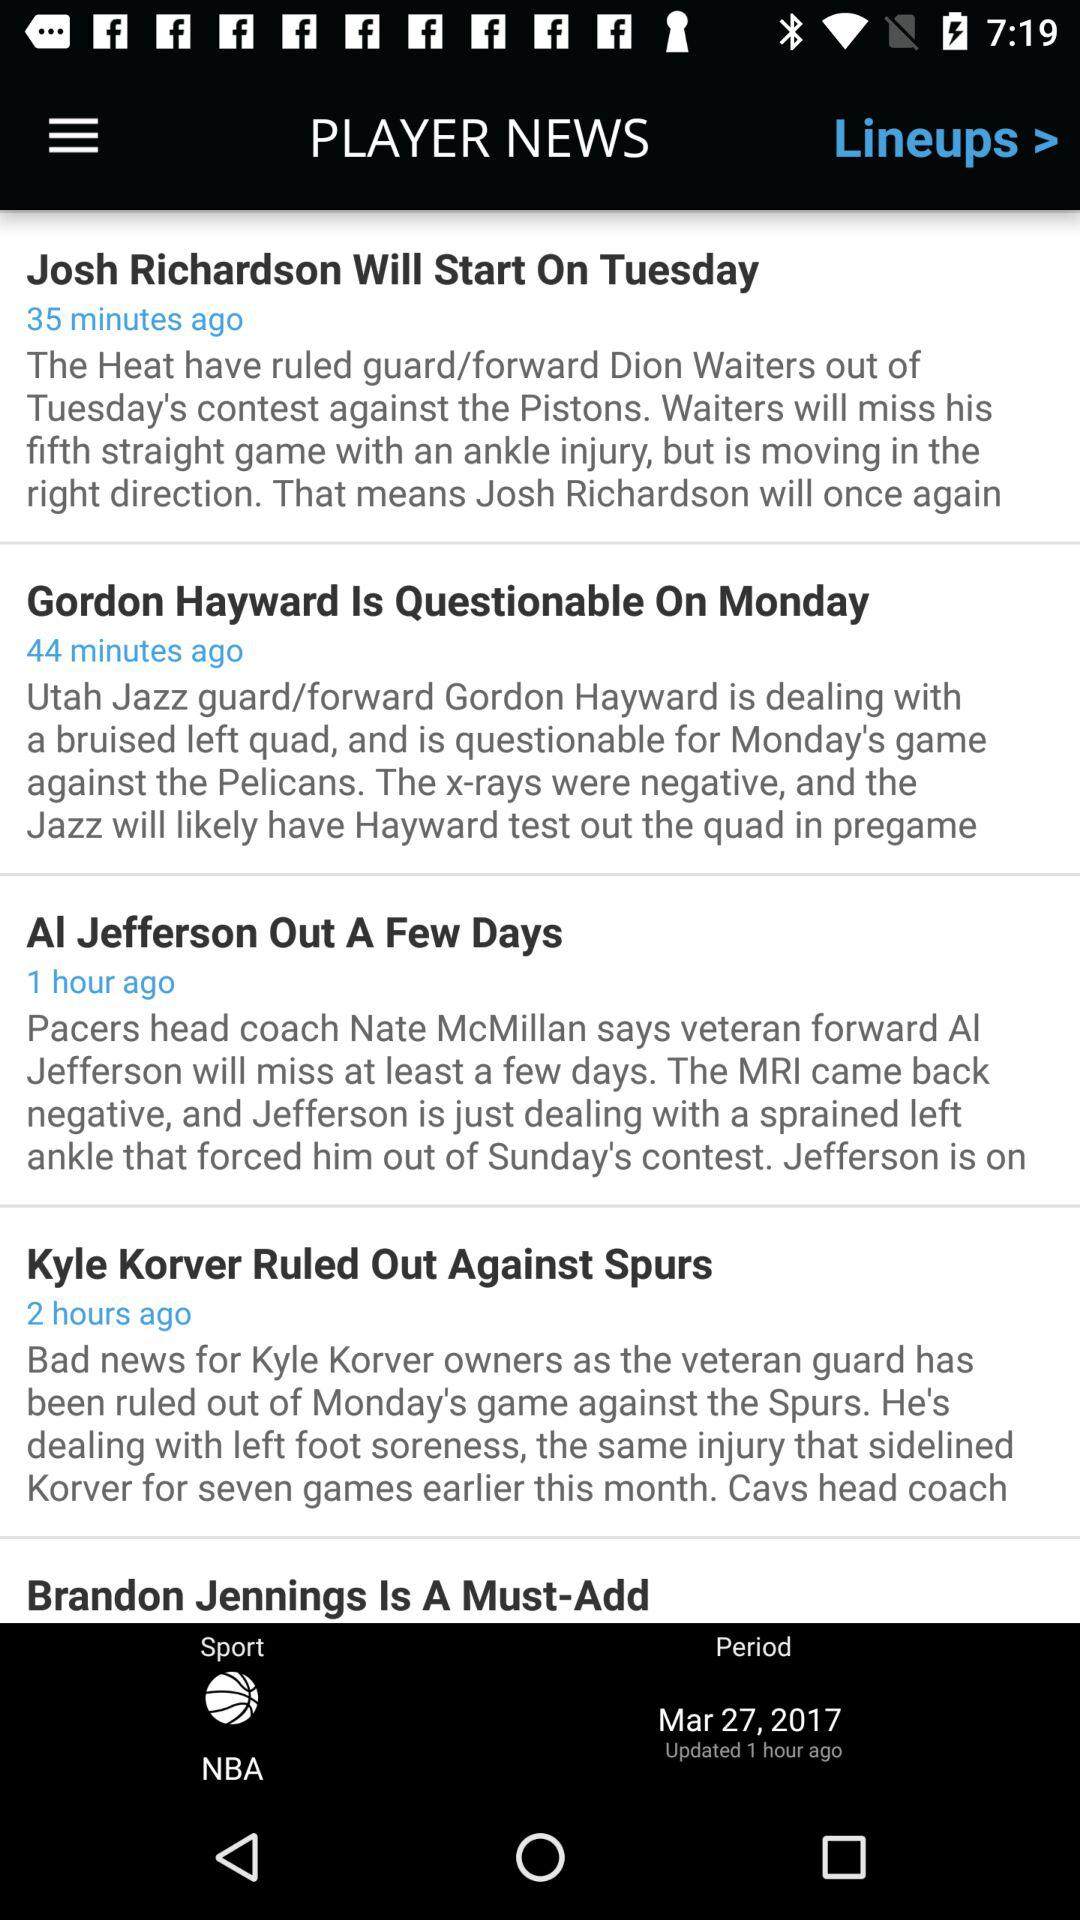How many hours ago was the Kyle Korver news published?
Answer the question using a single word or phrase. 2 